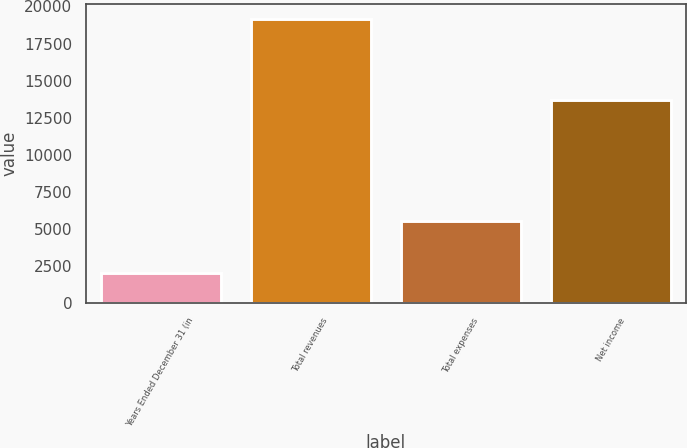Convert chart. <chart><loc_0><loc_0><loc_500><loc_500><bar_chart><fcel>Years Ended December 31 (in<fcel>Total revenues<fcel>Total expenses<fcel>Net income<nl><fcel>2013<fcel>19181<fcel>5515<fcel>13666<nl></chart> 